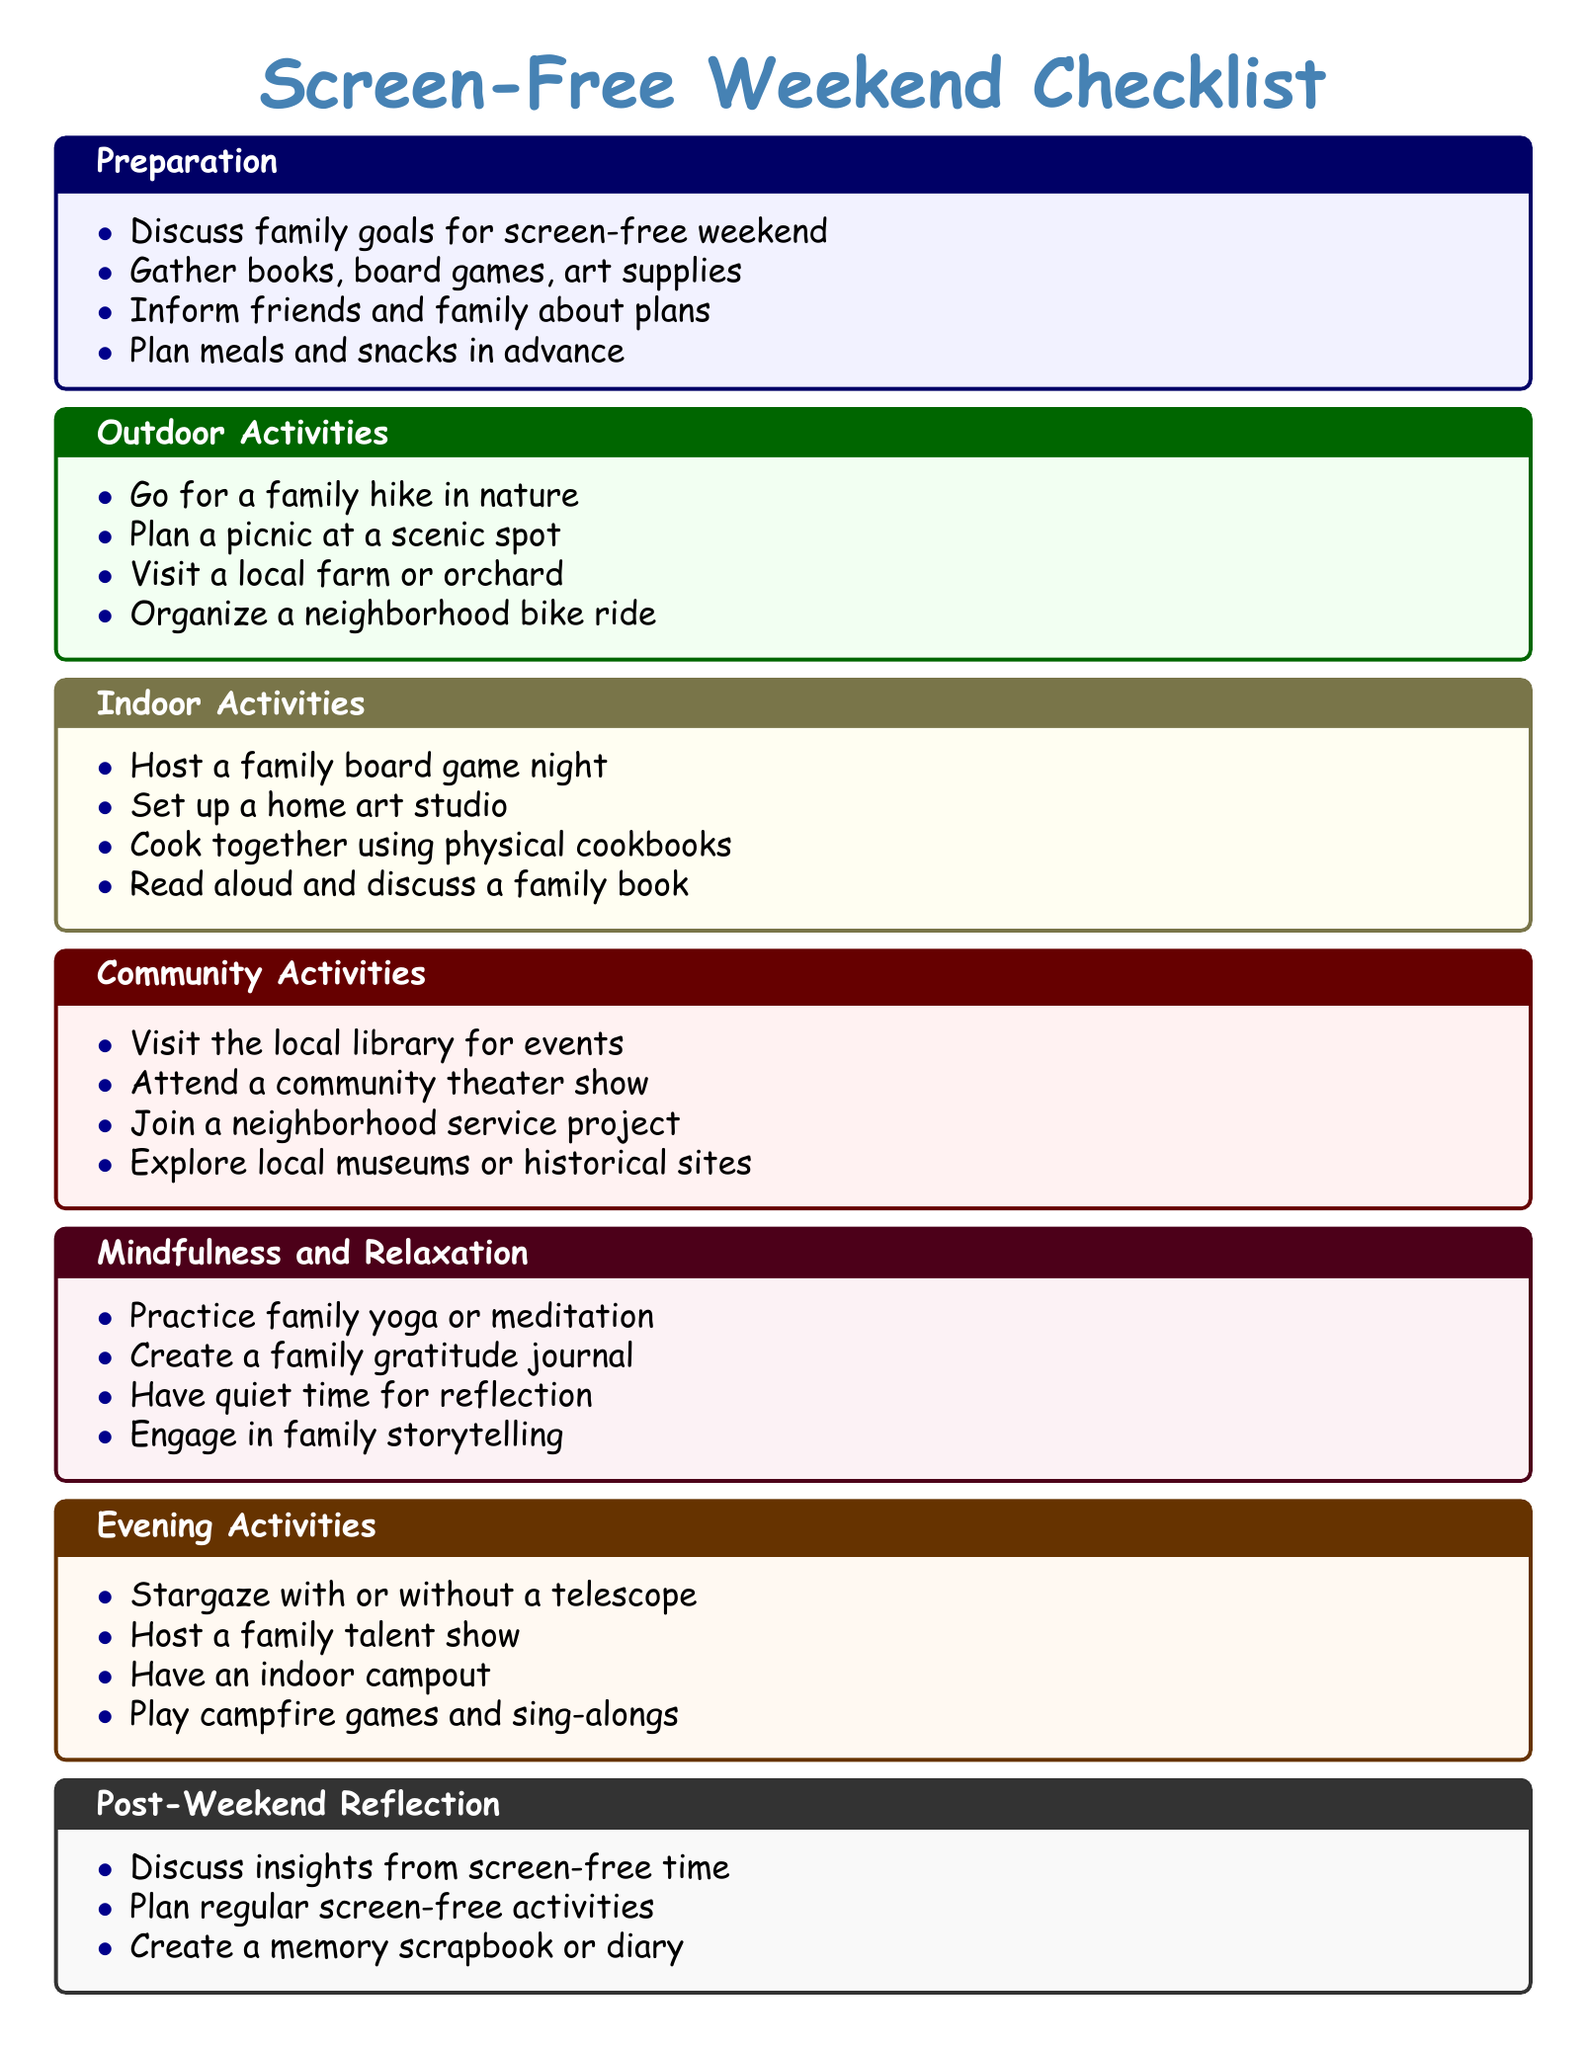what is the title of the checklist? The title of the checklist is prominently displayed at the top of the document.
Answer: Screen-Free Weekend Checklist how many categories are in the checklist? The checklist contains several different sections, each representing a category of activities.
Answer: 6 name one outdoor activity listed. One of the items in the outdoor activities section is an example of what families can do.
Answer: Go for a family hike in nature what is one type of mindfulness activity suggested? The mindfulness and relaxation section offers several suggestions for families to engage in together.
Answer: Practice family yoga or meditation what is recommended for post-weekend reflection? The post-weekend reflection section suggests how families can think about their experiences.
Answer: Discuss insights from screen-free time which section includes cooking activities? The indoor activities section outlines ways families can bond while engaging in creative or practical tasks.
Answer: Indoor Activities how can families engage with their community according to the checklist? The community activities section provides suggestions for families to interact with their local area.
Answer: Visit the local library for events how many evening activities are listed? The evening activities section includes multiple options for family fun at night.
Answer: 4 